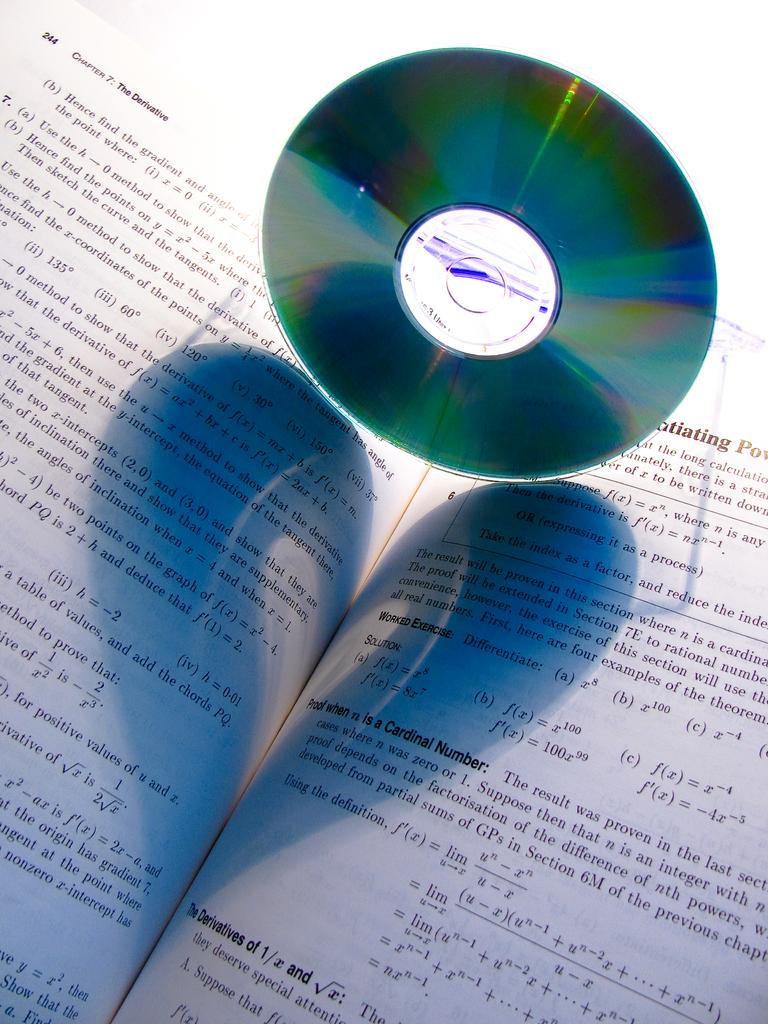<image>
Relay a brief, clear account of the picture shown. An open textbook open to chapter 7 with a CD above it 